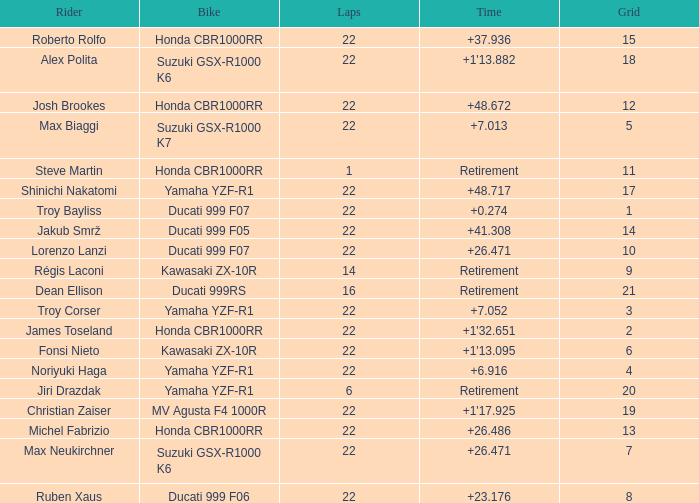What is the total grid number when Fonsi Nieto had more than 22 laps? 0.0. 